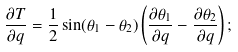<formula> <loc_0><loc_0><loc_500><loc_500>\frac { \partial T } { \partial q } = \frac { 1 } { 2 } \sin ( \theta _ { 1 } - \theta _ { 2 } ) \left ( \frac { \partial \theta _ { 1 } } { \partial q } - \frac { \partial \theta _ { 2 } } { \partial q } \right ) ;</formula> 